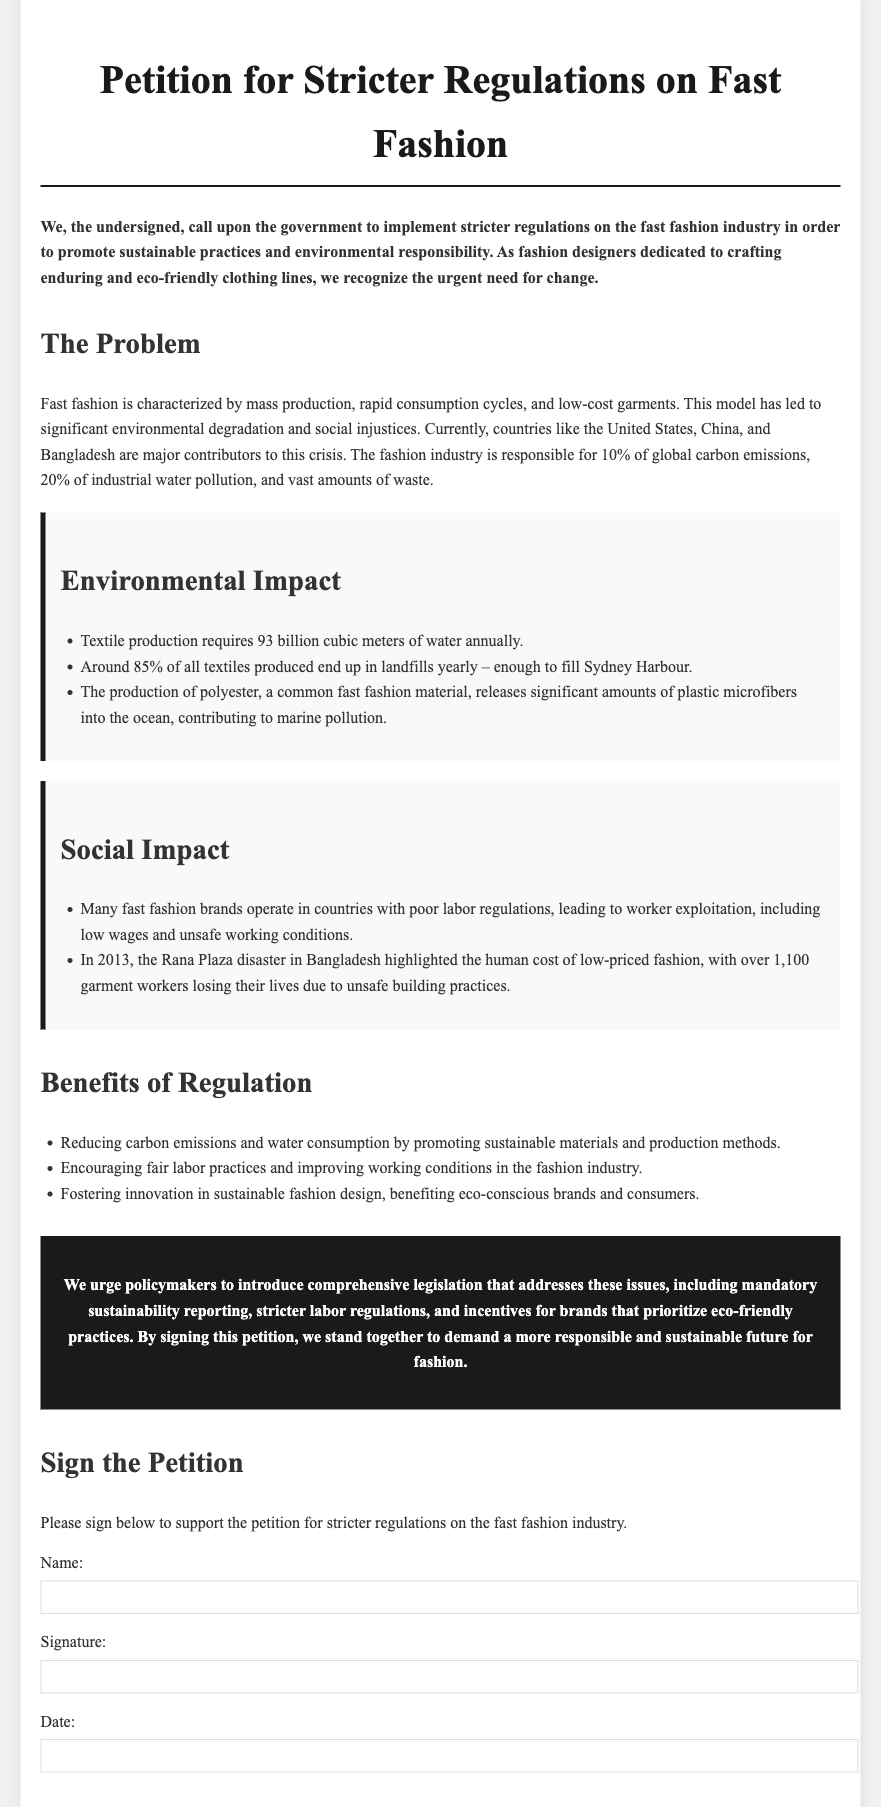What is the title of the petition? The title of the petition is presented at the top of the document, stating its purpose clearly.
Answer: Petition for Stricter Regulations on Fast Fashion What percentage of global carbon emissions is attributed to the fashion industry? This percentage is mentioned in the document under the problem section, highlighting the industry's significant environmental impact.
Answer: 10% What tragic event is mentioned in relation to fast fashion? The document references a specific disaster to emphasize the social impact of fast fashion, which serves as a significant historical example.
Answer: Rana Plaza disaster What is the annual requirement of water for textile production? This statistic is provided in the environmental impact section, illustrating the resource intensity of the textile industry.
Answer: 93 billion cubic meters What type of practices does the petition urge policymakers to prioritize? The petition advocates for a specific focus in legislative actions related to fashion industry practices.
Answer: Eco-friendly practices How many garment workers died in the Rana Plaza disaster? This tragic statistic is included to underline the human cost of fast fashion practices and regulations.
Answer: Over 1,100 What is one benefit of stricter regulations according to the petition? The document lists several benefits under the section related to regulation impacts on sustainability and labor, highlighting key areas of improvement.
Answer: Reducing carbon emissions What aspect of fast fashion is emphasized in the social impact section? The social impact section addresses specific issues relating to worker conditions and ethical practices in the fashion industry.
Answer: Worker exploitation How does the document call for action from policymakers? The document incorporates a strong call to action for specific business practices and legislative changes related to the environment.
Answer: Comprehensive legislation 